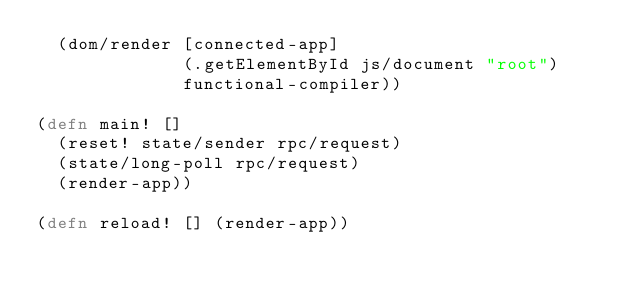<code> <loc_0><loc_0><loc_500><loc_500><_Clojure_>  (dom/render [connected-app]
              (.getElementById js/document "root")
              functional-compiler))

(defn main! []
  (reset! state/sender rpc/request)
  (state/long-poll rpc/request)
  (render-app))

(defn reload! [] (render-app))
</code> 